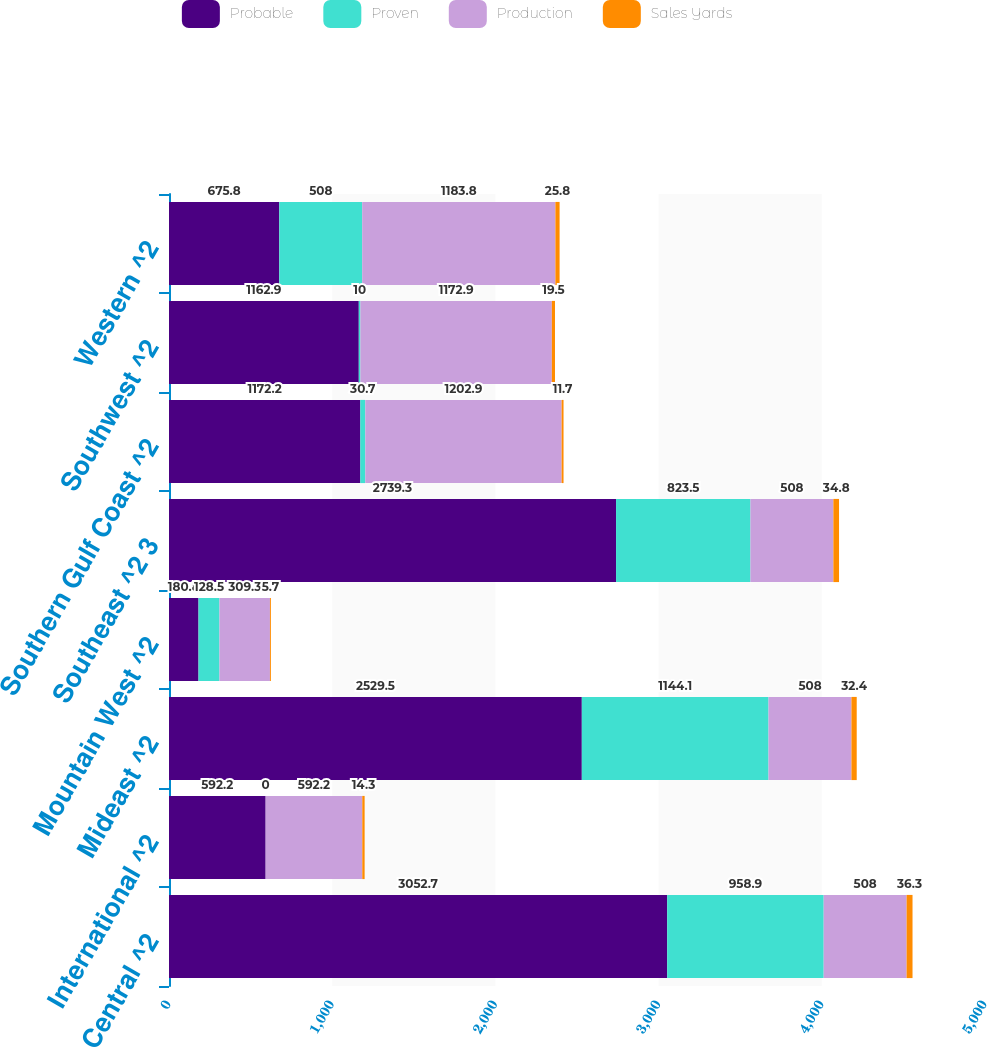<chart> <loc_0><loc_0><loc_500><loc_500><stacked_bar_chart><ecel><fcel>Central ^2<fcel>International ^2<fcel>Mideast ^2<fcel>Mountain West ^2<fcel>Southeast ^2 3<fcel>Southern Gulf Coast ^2<fcel>Southwest ^2<fcel>Western ^2<nl><fcel>Probable<fcel>3052.7<fcel>592.2<fcel>2529.5<fcel>180.8<fcel>2739.3<fcel>1172.2<fcel>1162.9<fcel>675.8<nl><fcel>Proven<fcel>958.9<fcel>0<fcel>1144.1<fcel>128.5<fcel>823.5<fcel>30.7<fcel>10<fcel>508<nl><fcel>Production<fcel>508<fcel>592.2<fcel>508<fcel>309.3<fcel>508<fcel>1202.9<fcel>1172.9<fcel>1183.8<nl><fcel>Sales Yards<fcel>36.3<fcel>14.3<fcel>32.4<fcel>5.7<fcel>34.8<fcel>11.7<fcel>19.5<fcel>25.8<nl></chart> 